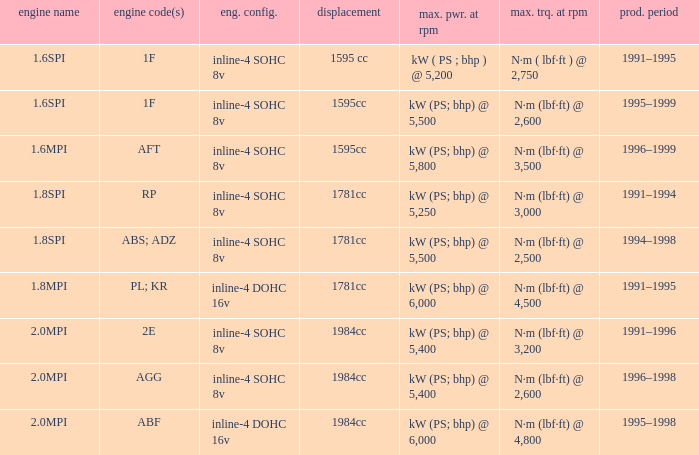What is the maximum power of engine code 2e? Kw (ps; bhp) @ 5,400. 